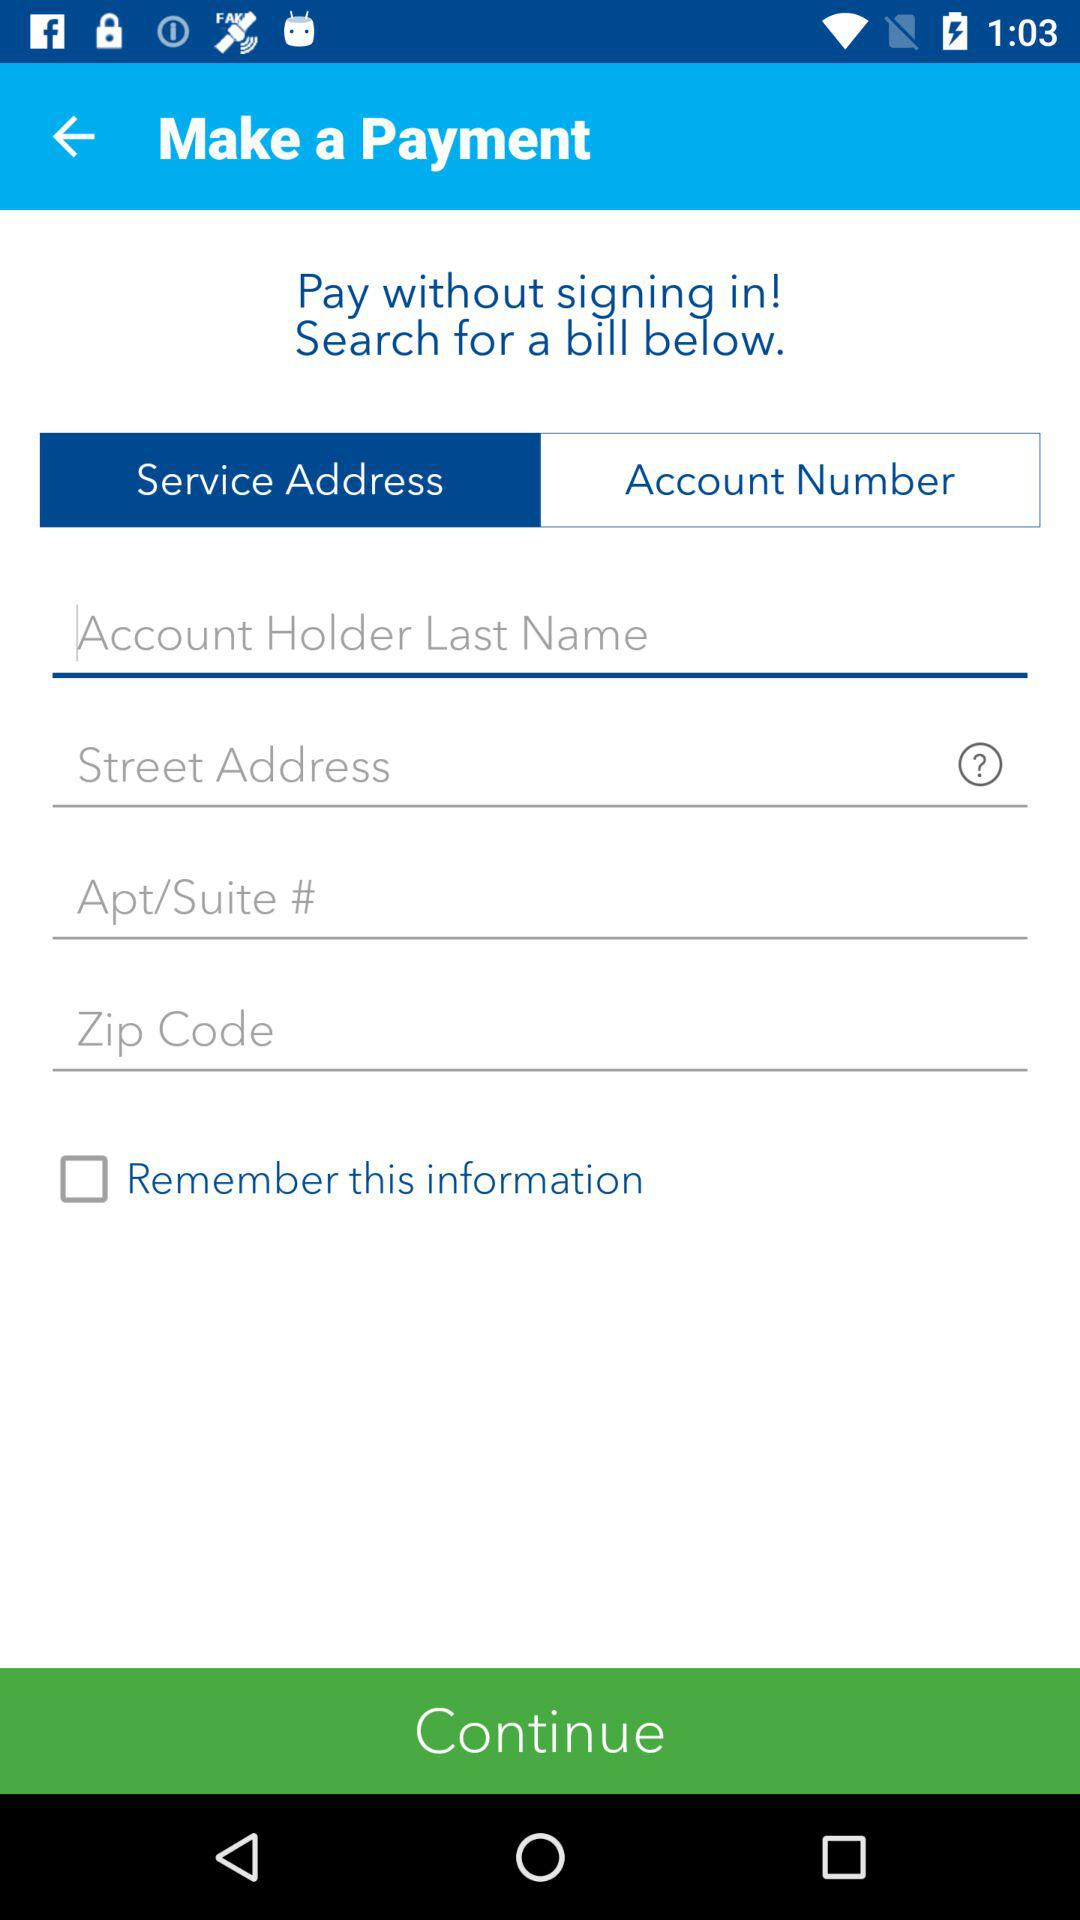Which tab is selected? The selected tab is "Service Address". 